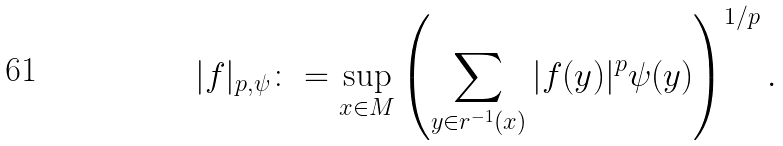Convert formula to latex. <formula><loc_0><loc_0><loc_500><loc_500>| f | _ { p , \psi } \colon = \sup _ { x \in M } \left ( \sum _ { y \in r ^ { - 1 } ( x ) } | f ( y ) | ^ { p } \psi ( y ) \right ) ^ { 1 / p } .</formula> 